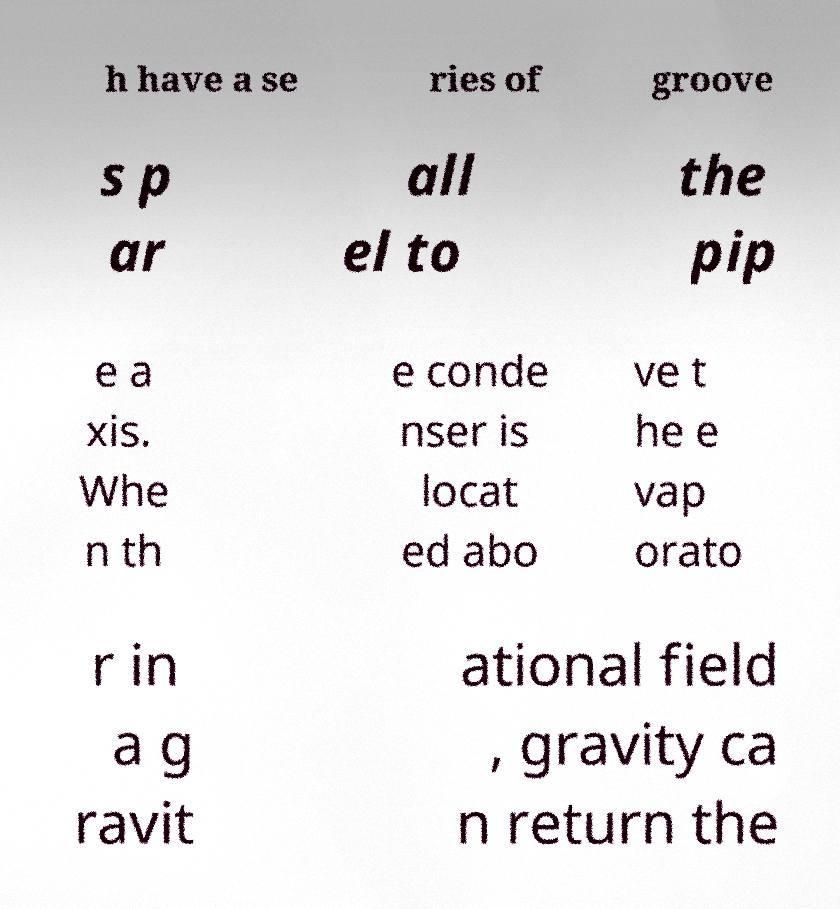Could you assist in decoding the text presented in this image and type it out clearly? h have a se ries of groove s p ar all el to the pip e a xis. Whe n th e conde nser is locat ed abo ve t he e vap orato r in a g ravit ational field , gravity ca n return the 